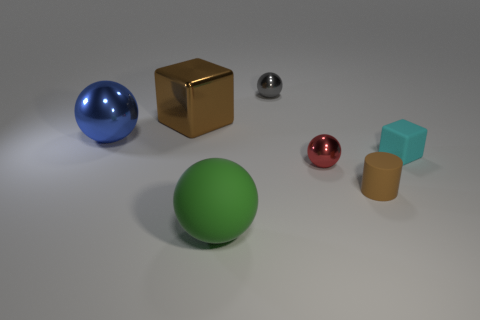The shiny cube that is the same color as the tiny cylinder is what size?
Keep it short and to the point. Large. There is a small red object; is its shape the same as the brown thing that is behind the blue metallic thing?
Keep it short and to the point. No. Do the brown object behind the cyan block and the tiny cyan rubber object have the same shape?
Keep it short and to the point. Yes. What number of things are both behind the big green thing and in front of the large blue metal sphere?
Give a very brief answer. 3. What number of other objects are the same size as the cyan thing?
Your response must be concise. 3. Are there an equal number of red metallic balls on the left side of the brown block and tiny things?
Offer a very short reply. No. There is a block left of the matte sphere; is its color the same as the small object that is in front of the red thing?
Make the answer very short. Yes. There is a object that is both on the left side of the gray metallic sphere and on the right side of the brown shiny object; what material is it made of?
Your answer should be compact. Rubber. The rubber ball is what color?
Give a very brief answer. Green. What number of other things are the same shape as the big blue thing?
Make the answer very short. 3. 